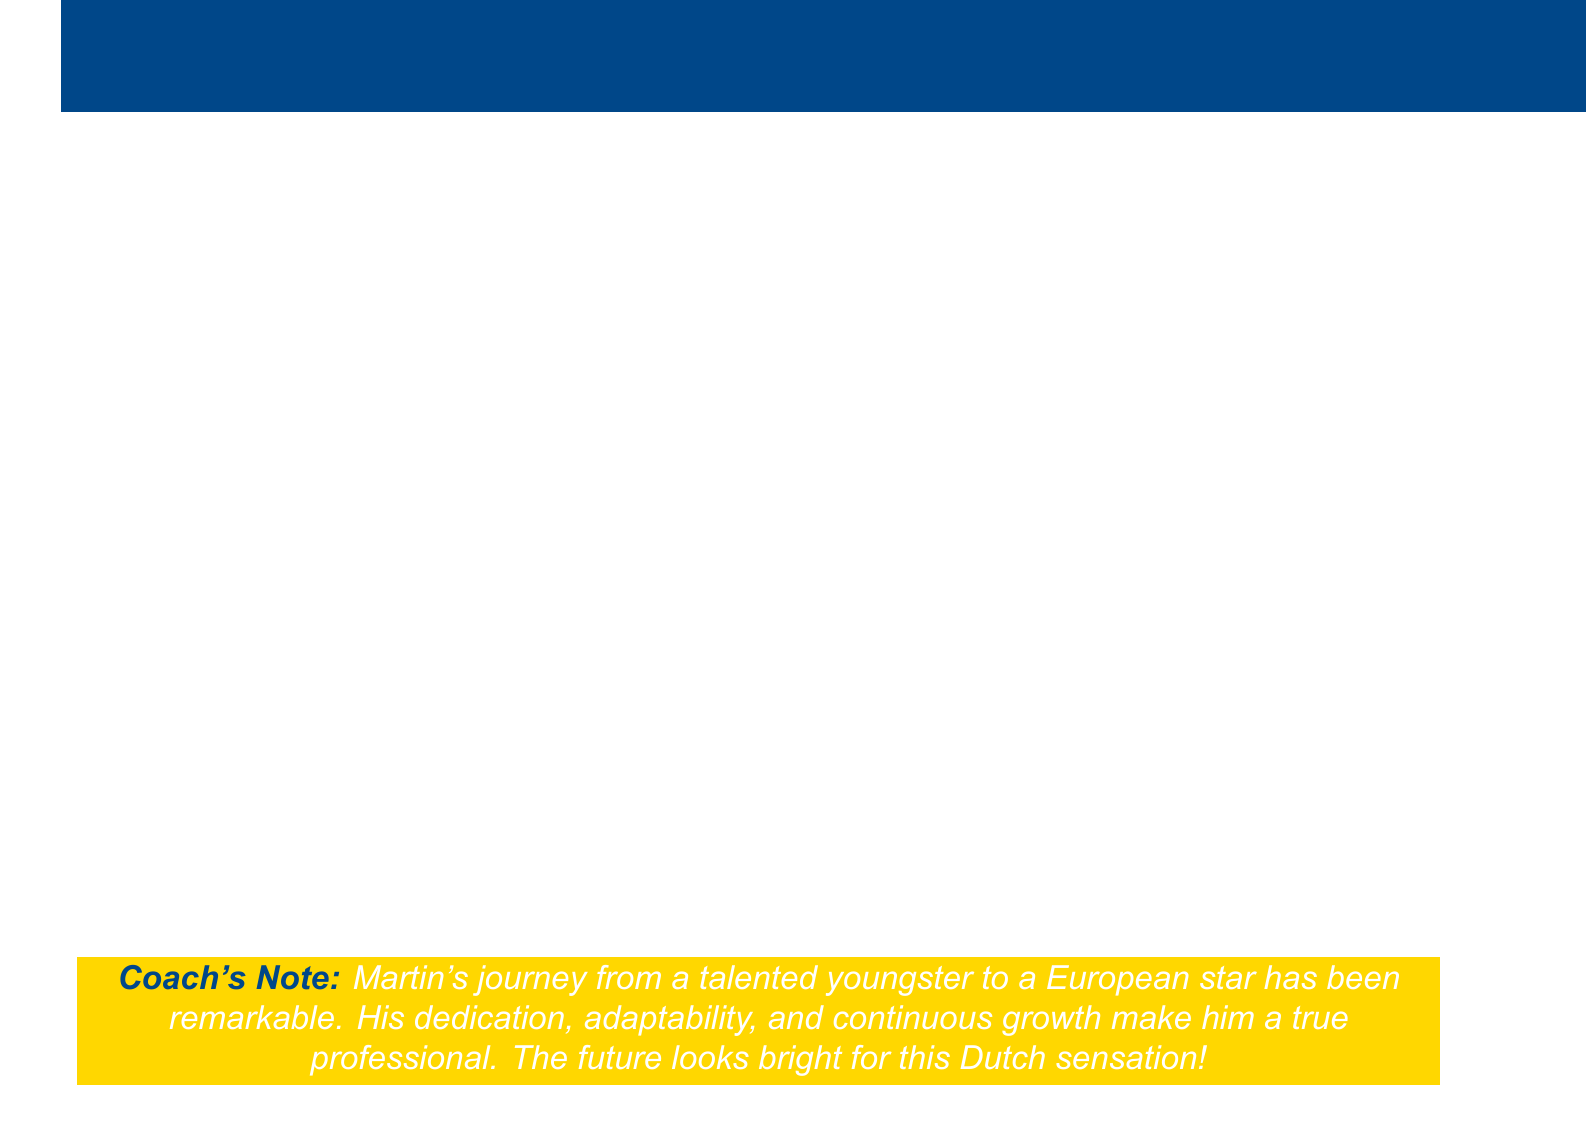What age was Martin when he was first scouted? Martin was first scouted at age 15 during a local tournament.
Answer: 15 Which youth academy did Martin join? Martin joined the PSV Eindhoven youth academy at age 16.
Answer: PSV Eindhoven What was the fee for Martin’s transfer to Ajax? The transfer fee for Martin's move to Ajax was €15 million.
Answer: €15 million Who was Martin's coach during his early development at PSV? Phillip Cocu was Martin's head coach at PSV.
Answer: Phillip Cocu What key skill did Martin develop to enhance his wing play? Martin developed pinpoint crossing ability as a key asset for wing play.
Answer: Pinpoint crossing ability What achievement did Martin earn during his debut season in Eredivisie? Martin was named in the Eredivisie Team of the Month twice during his debut season.
Answer: Named in Eredivisie Team of the Month twice What landmark performance occurred in the UEFA Champions League? Martin achieved Man of the Match in the Round of 16 victory over Juventus.
Answer: Man of the Match against Juventus What aspect of Martin's development included working with a sports psychologist? Martin worked with a sports psychologist to manage pressure and develop mental fortitude.
Answer: Mental fortitude What potential career opportunity does Martin aim for within the next two seasons? Martin has a potential transfer opportunity to the Premier League or La Liga.
Answer: Premier League or La Liga What foundation does Martin consider establishing? Martin is considering establishing a charitable foundation to give back to the community in Eindhoven.
Answer: Charitable foundation in Eindhoven 